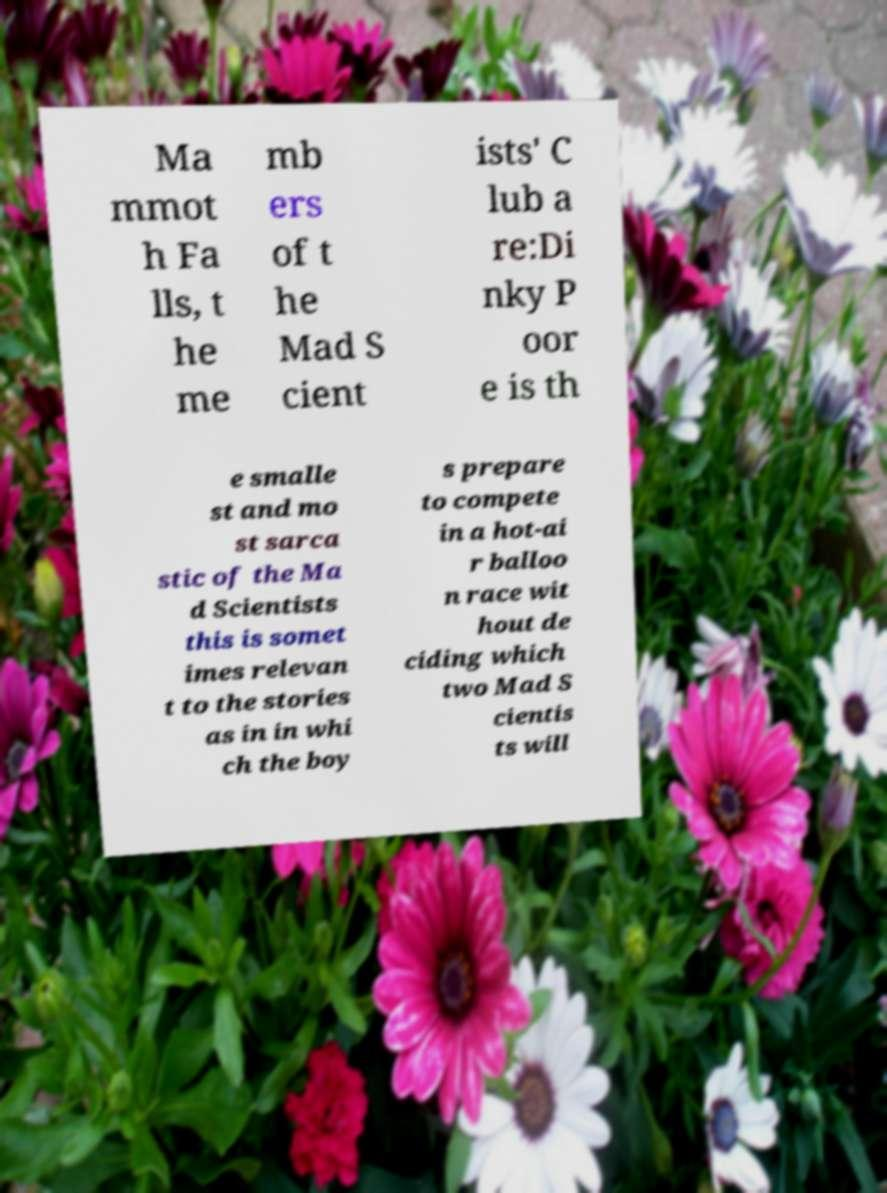Please read and relay the text visible in this image. What does it say? Ma mmot h Fa lls, t he me mb ers of t he Mad S cient ists' C lub a re:Di nky P oor e is th e smalle st and mo st sarca stic of the Ma d Scientists this is somet imes relevan t to the stories as in in whi ch the boy s prepare to compete in a hot-ai r balloo n race wit hout de ciding which two Mad S cientis ts will 